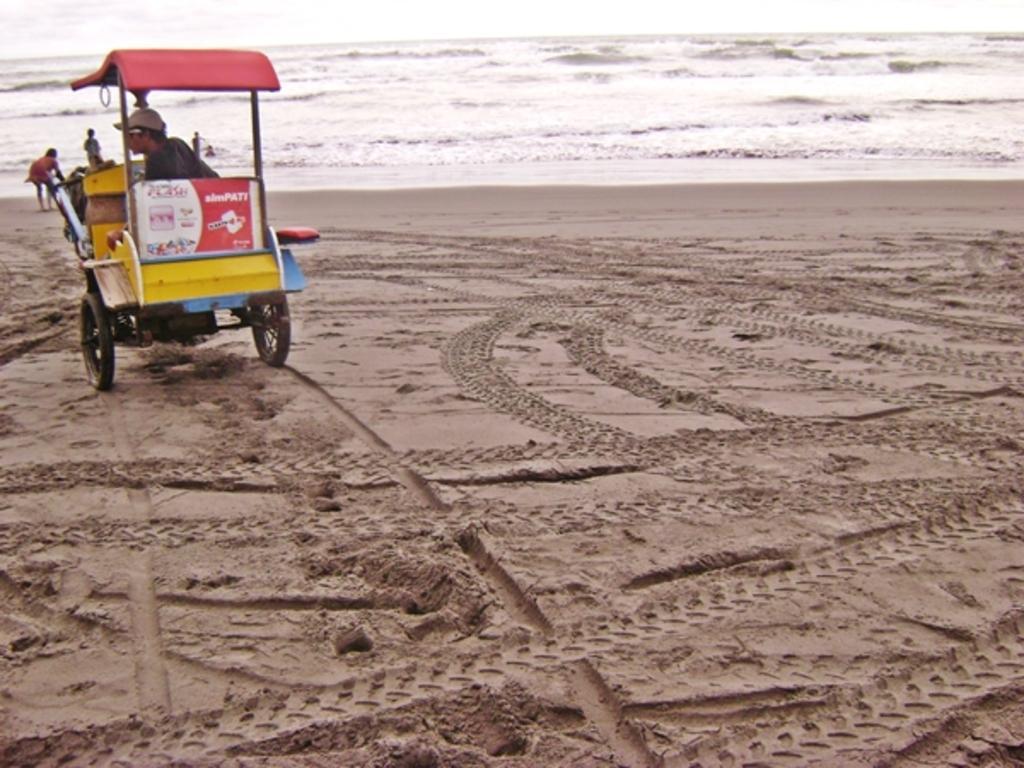Describe this image in one or two sentences. As we can see in the image there is cart, few people, sand and water. 